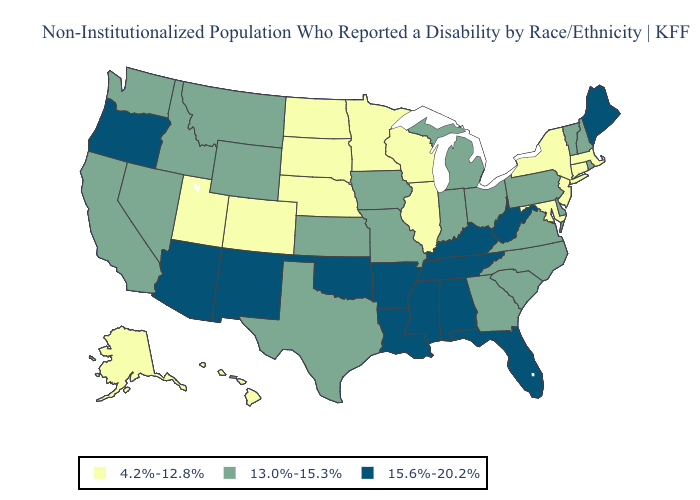Name the states that have a value in the range 15.6%-20.2%?
Quick response, please. Alabama, Arizona, Arkansas, Florida, Kentucky, Louisiana, Maine, Mississippi, New Mexico, Oklahoma, Oregon, Tennessee, West Virginia. Which states hav the highest value in the South?
Be succinct. Alabama, Arkansas, Florida, Kentucky, Louisiana, Mississippi, Oklahoma, Tennessee, West Virginia. What is the highest value in the West ?
Quick response, please. 15.6%-20.2%. Does New Mexico have the highest value in the USA?
Write a very short answer. Yes. Which states hav the highest value in the MidWest?
Keep it brief. Indiana, Iowa, Kansas, Michigan, Missouri, Ohio. Does the map have missing data?
Quick response, please. No. What is the lowest value in states that border Wyoming?
Write a very short answer. 4.2%-12.8%. Name the states that have a value in the range 15.6%-20.2%?
Write a very short answer. Alabama, Arizona, Arkansas, Florida, Kentucky, Louisiana, Maine, Mississippi, New Mexico, Oklahoma, Oregon, Tennessee, West Virginia. What is the lowest value in the West?
Short answer required. 4.2%-12.8%. How many symbols are there in the legend?
Answer briefly. 3. Does Connecticut have the same value as Minnesota?
Write a very short answer. Yes. Name the states that have a value in the range 4.2%-12.8%?
Give a very brief answer. Alaska, Colorado, Connecticut, Hawaii, Illinois, Maryland, Massachusetts, Minnesota, Nebraska, New Jersey, New York, North Dakota, South Dakota, Utah, Wisconsin. What is the value of Vermont?
Answer briefly. 13.0%-15.3%. Name the states that have a value in the range 4.2%-12.8%?
Concise answer only. Alaska, Colorado, Connecticut, Hawaii, Illinois, Maryland, Massachusetts, Minnesota, Nebraska, New Jersey, New York, North Dakota, South Dakota, Utah, Wisconsin. Among the states that border Maryland , which have the lowest value?
Short answer required. Delaware, Pennsylvania, Virginia. 